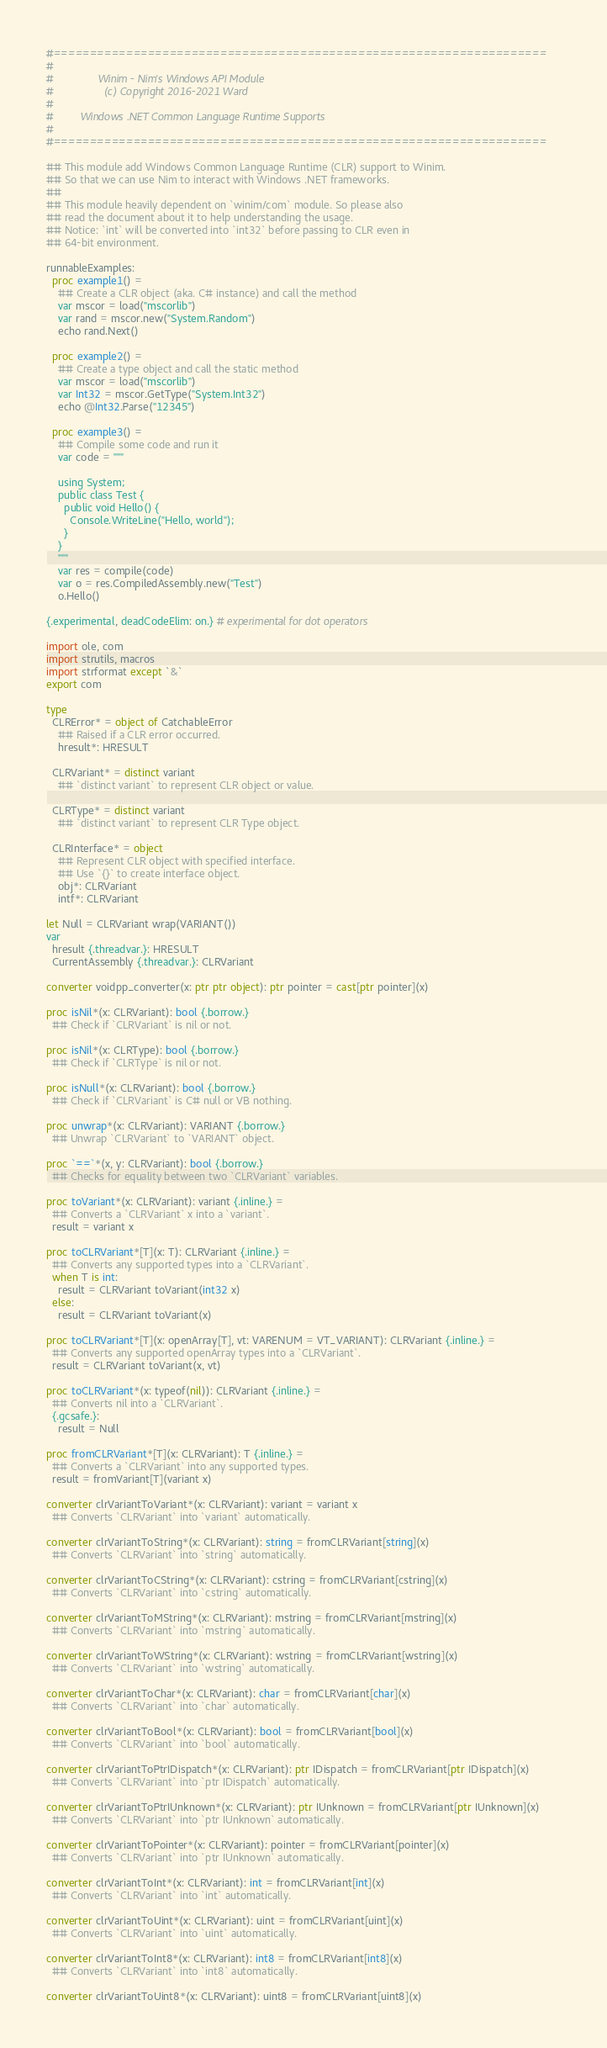Convert code to text. <code><loc_0><loc_0><loc_500><loc_500><_Nim_>#====================================================================
#
#               Winim - Nim's Windows API Module
#                 (c) Copyright 2016-2021 Ward
#
#         Windows .NET Common Language Runtime Supports
#
#====================================================================

## This module add Windows Common Language Runtime (CLR) support to Winim.
## So that we can use Nim to interact with Windows .NET frameworks.
##
## This module heavily dependent on `winim/com` module. So please also
## read the document about it to help understanding the usage.
## Notice: `int` will be converted into `int32` before passing to CLR even in
## 64-bit environment.

runnableExamples:
  proc example1() =
    ## Create a CLR object (aka. C# instance) and call the method
    var mscor = load("mscorlib")
    var rand = mscor.new("System.Random")
    echo rand.Next()

  proc example2() =
    ## Create a type object and call the static method
    var mscor = load("mscorlib")
    var Int32 = mscor.GetType("System.Int32")
    echo @Int32.Parse("12345")

  proc example3() =
    ## Compile some code and run it
    var code = """

    using System;
    public class Test {
      public void Hello() {
        Console.WriteLine("Hello, world");
      }
    }
    """
    var res = compile(code)
    var o = res.CompiledAssembly.new("Test")
    o.Hello()

{.experimental, deadCodeElim: on.} # experimental for dot operators

import ole, com
import strutils, macros
import strformat except `&`
export com

type
  CLRError* = object of CatchableError
    ## Raised if a CLR error occurred.
    hresult*: HRESULT

  CLRVariant* = distinct variant
    ## `distinct variant` to represent CLR object or value.

  CLRType* = distinct variant
    ## `distinct variant` to represent CLR Type object.

  CLRInterface* = object
    ## Represent CLR object with specified interface.
    ## Use `{}` to create interface object.
    obj*: CLRVariant
    intf*: CLRVariant

let Null = CLRVariant wrap(VARIANT())
var
  hresult {.threadvar.}: HRESULT
  CurrentAssembly {.threadvar.}: CLRVariant

converter voidpp_converter(x: ptr ptr object): ptr pointer = cast[ptr pointer](x)

proc isNil*(x: CLRVariant): bool {.borrow.}
  ## Check if `CLRVariant` is nil or not.

proc isNil*(x: CLRType): bool {.borrow.}
  ## Check if `CLRType` is nil or not.

proc isNull*(x: CLRVariant): bool {.borrow.}
  ## Check if `CLRVariant` is C# null or VB nothing.

proc unwrap*(x: CLRVariant): VARIANT {.borrow.}
  ## Unwrap `CLRVariant` to `VARIANT` object.

proc `==`*(x, y: CLRVariant): bool {.borrow.}
  ## Checks for equality between two `CLRVariant` variables.

proc toVariant*(x: CLRVariant): variant {.inline.} =
  ## Converts a `CLRVariant` x into a `variant`.
  result = variant x

proc toCLRVariant*[T](x: T): CLRVariant {.inline.} =
  ## Converts any supported types into a `CLRVariant`.
  when T is int:
    result = CLRVariant toVariant(int32 x)
  else:
    result = CLRVariant toVariant(x)

proc toCLRVariant*[T](x: openArray[T], vt: VARENUM = VT_VARIANT): CLRVariant {.inline.} =
  ## Converts any supported openArray types into a `CLRVariant`.
  result = CLRVariant toVariant(x, vt)

proc toCLRVariant*(x: typeof(nil)): CLRVariant {.inline.} =
  ## Converts nil into a `CLRVariant`.
  {.gcsafe.}:
    result = Null

proc fromCLRVariant*[T](x: CLRVariant): T {.inline.} =
  ## Converts a `CLRVariant` into any supported types.
  result = fromVariant[T](variant x)

converter clrVariantToVariant*(x: CLRVariant): variant = variant x
  ## Converts `CLRVariant` into `variant` automatically.

converter clrVariantToString*(x: CLRVariant): string = fromCLRVariant[string](x)
  ## Converts `CLRVariant` into `string` automatically.

converter clrVariantToCString*(x: CLRVariant): cstring = fromCLRVariant[cstring](x)
  ## Converts `CLRVariant` into `cstring` automatically.

converter clrVariantToMString*(x: CLRVariant): mstring = fromCLRVariant[mstring](x)
  ## Converts `CLRVariant` into `mstring` automatically.

converter clrVariantToWString*(x: CLRVariant): wstring = fromCLRVariant[wstring](x)
  ## Converts `CLRVariant` into `wstring` automatically.

converter clrVariantToChar*(x: CLRVariant): char = fromCLRVariant[char](x)
  ## Converts `CLRVariant` into `char` automatically.

converter clrVariantToBool*(x: CLRVariant): bool = fromCLRVariant[bool](x)
  ## Converts `CLRVariant` into `bool` automatically.

converter clrVariantToPtrIDispatch*(x: CLRVariant): ptr IDispatch = fromCLRVariant[ptr IDispatch](x)
  ## Converts `CLRVariant` into `ptr IDispatch` automatically.

converter clrVariantToPtrIUnknown*(x: CLRVariant): ptr IUnknown = fromCLRVariant[ptr IUnknown](x)
  ## Converts `CLRVariant` into `ptr IUnknown` automatically.

converter clrVariantToPointer*(x: CLRVariant): pointer = fromCLRVariant[pointer](x)
  ## Converts `CLRVariant` into `ptr IUnknown` automatically.

converter clrVariantToInt*(x: CLRVariant): int = fromCLRVariant[int](x)
  ## Converts `CLRVariant` into `int` automatically.

converter clrVariantToUint*(x: CLRVariant): uint = fromCLRVariant[uint](x)
  ## Converts `CLRVariant` into `uint` automatically.

converter clrVariantToInt8*(x: CLRVariant): int8 = fromCLRVariant[int8](x)
  ## Converts `CLRVariant` into `int8` automatically.

converter clrVariantToUint8*(x: CLRVariant): uint8 = fromCLRVariant[uint8](x)</code> 